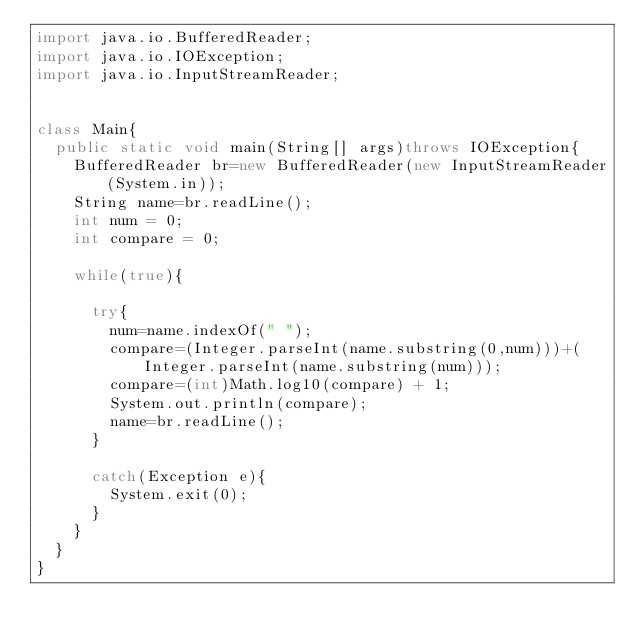Convert code to text. <code><loc_0><loc_0><loc_500><loc_500><_Java_>import java.io.BufferedReader;
import java.io.IOException;
import java.io.InputStreamReader;


class Main{
	public static void main(String[] args)throws IOException{
		BufferedReader br=new BufferedReader(new InputStreamReader(System.in));
		String name=br.readLine();
		int num = 0;
		int compare = 0;

		while(true){

			try{
				num=name.indexOf(" ");
				compare=(Integer.parseInt(name.substring(0,num)))+(Integer.parseInt(name.substring(num)));
				compare=(int)Math.log10(compare) + 1;
				System.out.println(compare);
				name=br.readLine();
			}

			catch(Exception e){
				System.exit(0);
			}
		}
	}
}</code> 